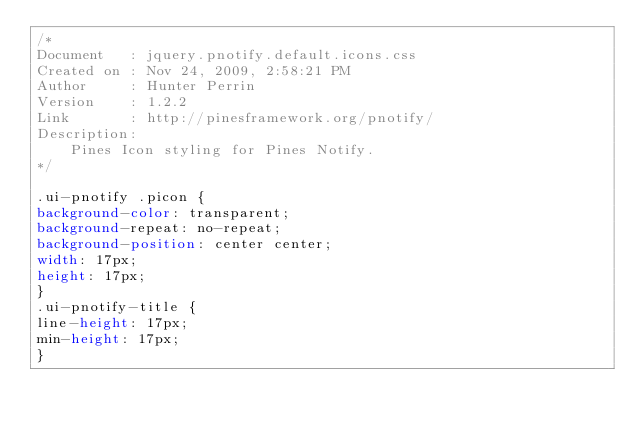<code> <loc_0><loc_0><loc_500><loc_500><_CSS_>/*
Document   : jquery.pnotify.default.icons.css
Created on : Nov 24, 2009, 2:58:21 PM
Author     : Hunter Perrin
Version    : 1.2.2
Link       : http://pinesframework.org/pnotify/
Description:
	Pines Icon styling for Pines Notify.
*/

.ui-pnotify .picon {
background-color: transparent;
background-repeat: no-repeat;
background-position: center center;
width: 17px;
height: 17px;
}
.ui-pnotify-title {
line-height: 17px;
min-height: 17px;
}</code> 